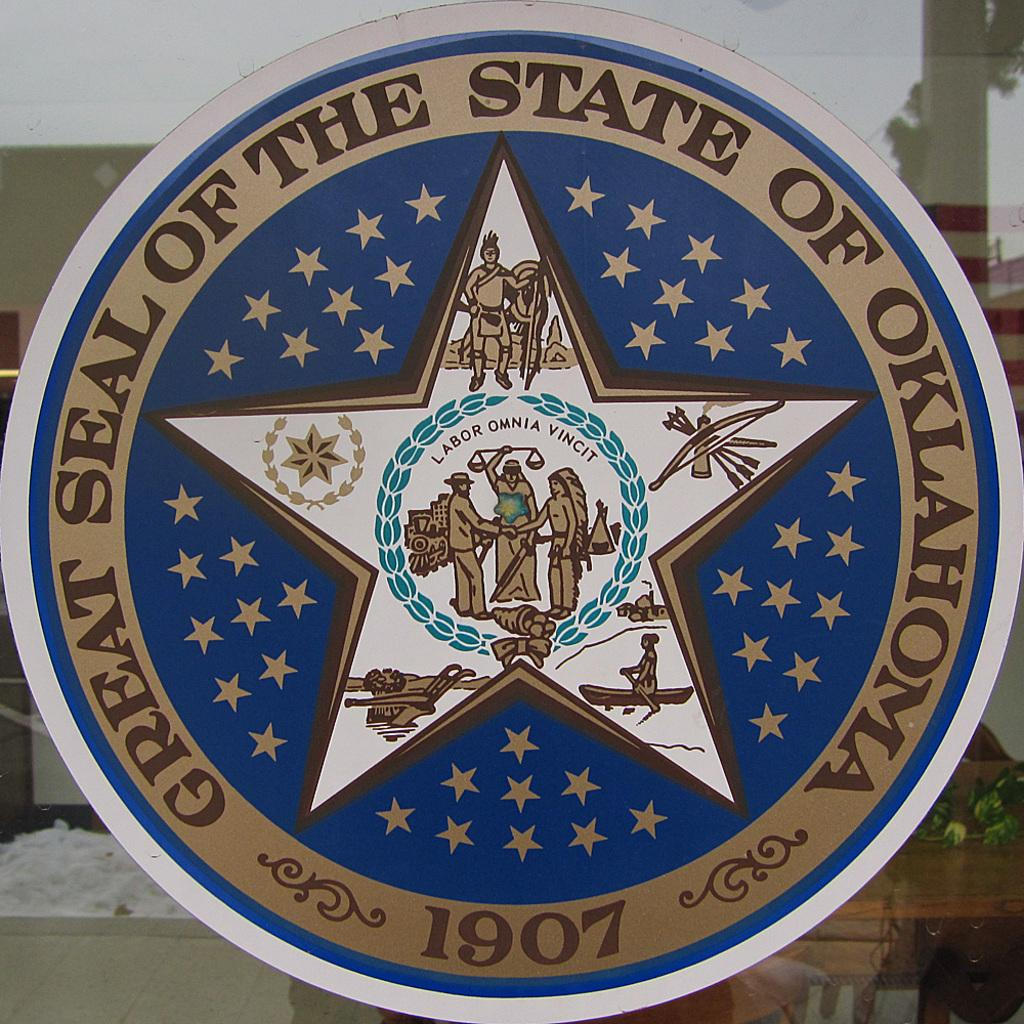What shape is the board in the image? The board in the image is circular. What is written or depicted on the board? There is text and pictures of people on the board. What can be seen near the board in the image? There is a glass in the image. What type of surface is visible in the image? There is a floor in the image. How many trees are visible in the image? There are no trees visible in the image. What is the price of the gate shown in the image? There is no gate present in the image, so it is not possible to determine its price. 